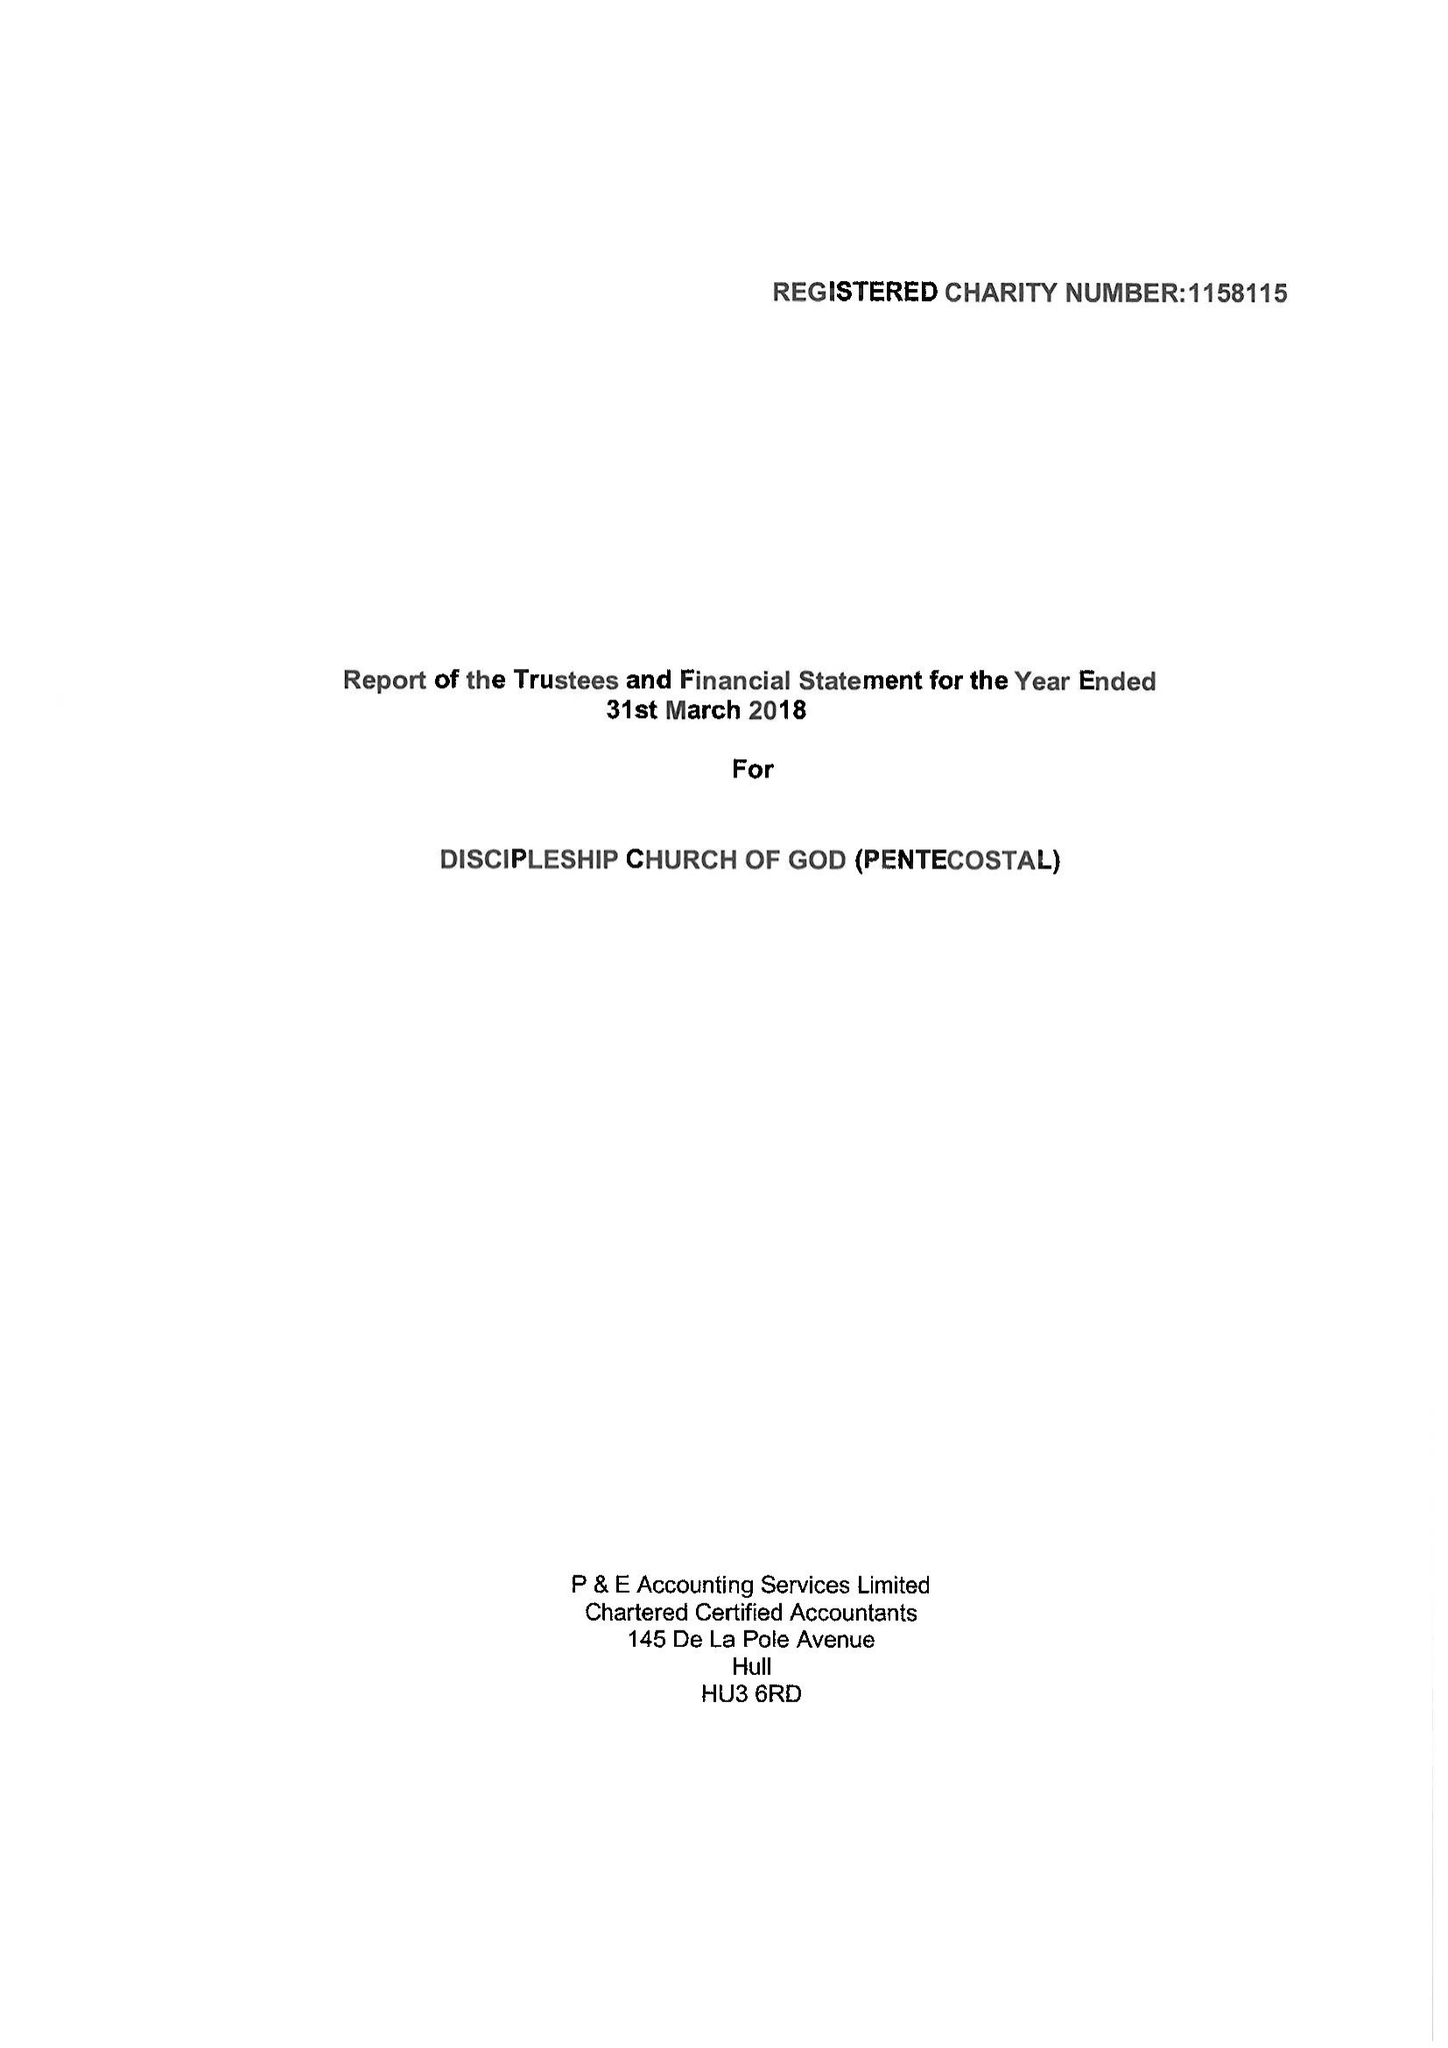What is the value for the income_annually_in_british_pounds?
Answer the question using a single word or phrase. 10488.66 